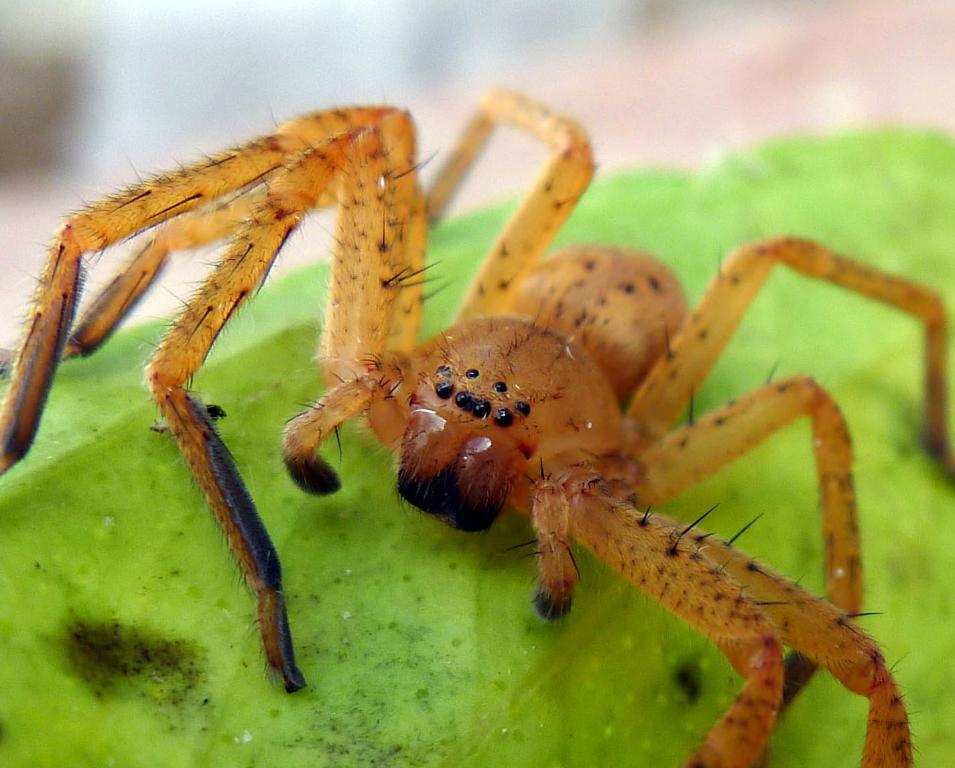What is the main subject of the image? There is a spider in the image. Where is the spider located? The spider is on a green surface that resembles a leaf. Can you describe the background of the image? The background of the image is blurred. What type of celery is being used as a tent in the image? There is no celery or tent present in the image; it features a spider on a green surface that resembles a leaf. 